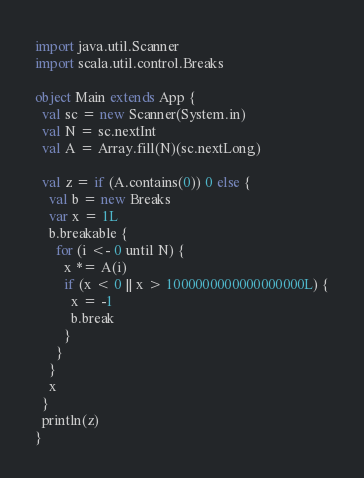Convert code to text. <code><loc_0><loc_0><loc_500><loc_500><_Scala_>import java.util.Scanner
import scala.util.control.Breaks

object Main extends App {
  val sc = new Scanner(System.in)
  val N = sc.nextInt
  val A = Array.fill(N)(sc.nextLong)

  val z = if (A.contains(0)) 0 else {
    val b = new Breaks
    var x = 1L
    b.breakable {
      for (i <- 0 until N) {
        x *= A(i)
        if (x < 0 || x > 1000000000000000000L) {
          x = -1
          b.break
        }
      }
    }
    x
  }
  println(z)
}
</code> 